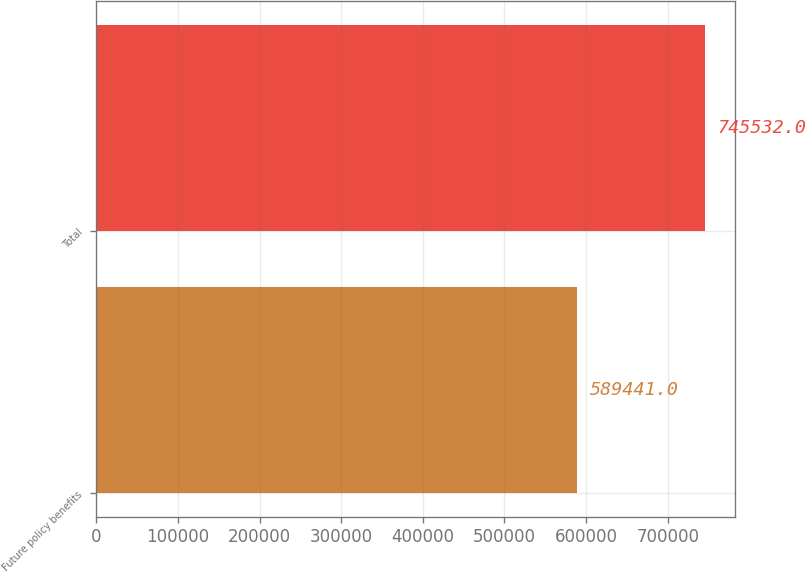Convert chart. <chart><loc_0><loc_0><loc_500><loc_500><bar_chart><fcel>Future policy benefits<fcel>Total<nl><fcel>589441<fcel>745532<nl></chart> 